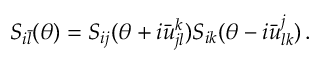Convert formula to latex. <formula><loc_0><loc_0><loc_500><loc_500>S _ { i \bar { l } } ( \theta ) = S _ { i j } ( \theta + i \bar { u } _ { j l } ^ { k } ) S _ { i k } ( \theta - i \bar { u } _ { l k } ^ { j } ) \, .</formula> 